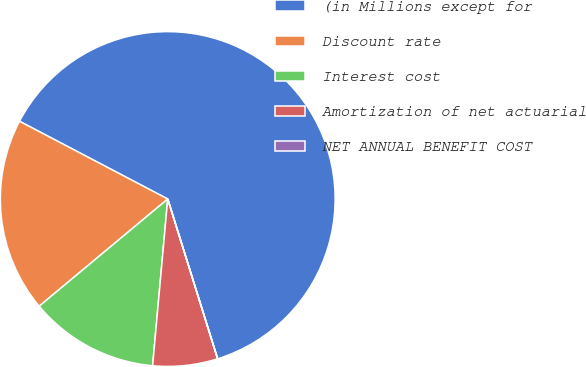Convert chart. <chart><loc_0><loc_0><loc_500><loc_500><pie_chart><fcel>(in Millions except for<fcel>Discount rate<fcel>Interest cost<fcel>Amortization of net actuarial<fcel>NET ANNUAL BENEFIT COST<nl><fcel>62.49%<fcel>18.75%<fcel>12.5%<fcel>6.25%<fcel>0.01%<nl></chart> 